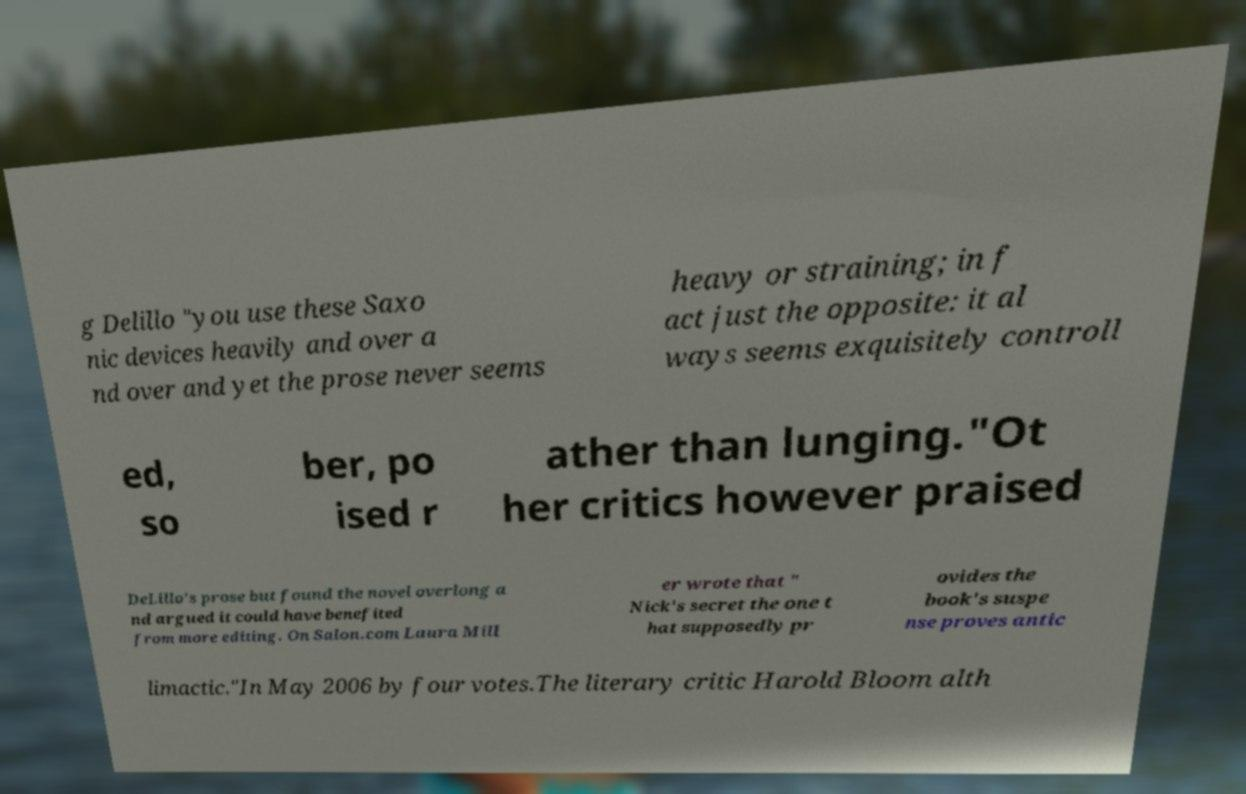Please identify and transcribe the text found in this image. g Delillo "you use these Saxo nic devices heavily and over a nd over and yet the prose never seems heavy or straining; in f act just the opposite: it al ways seems exquisitely controll ed, so ber, po ised r ather than lunging."Ot her critics however praised DeLillo's prose but found the novel overlong a nd argued it could have benefited from more editing. On Salon.com Laura Mill er wrote that " Nick's secret the one t hat supposedly pr ovides the book's suspe nse proves antic limactic."In May 2006 by four votes.The literary critic Harold Bloom alth 